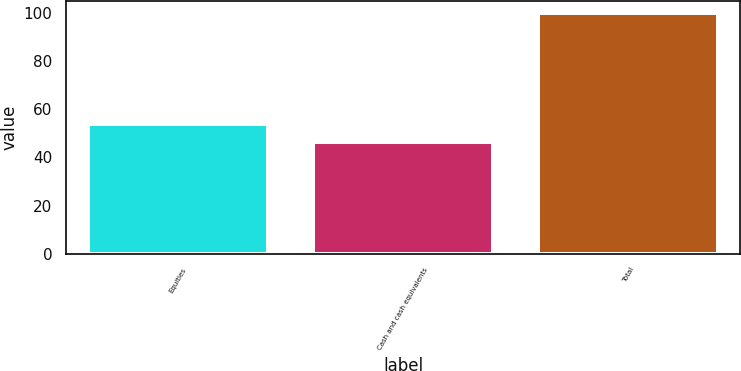<chart> <loc_0><loc_0><loc_500><loc_500><bar_chart><fcel>Equities<fcel>Cash and cash equivalents<fcel>Total<nl><fcel>53.7<fcel>46.3<fcel>100<nl></chart> 